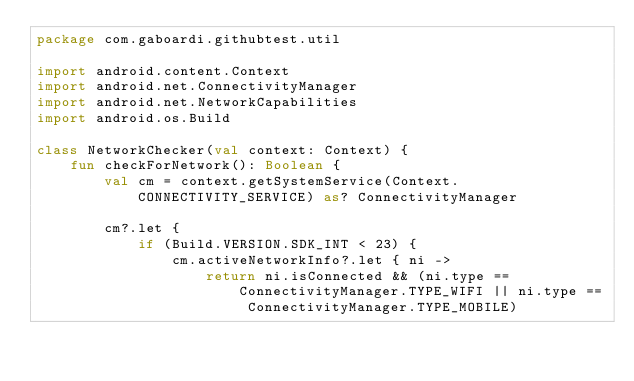<code> <loc_0><loc_0><loc_500><loc_500><_Kotlin_>package com.gaboardi.githubtest.util

import android.content.Context
import android.net.ConnectivityManager
import android.net.NetworkCapabilities
import android.os.Build

class NetworkChecker(val context: Context) {
    fun checkForNetwork(): Boolean {
        val cm = context.getSystemService(Context.CONNECTIVITY_SERVICE) as? ConnectivityManager

        cm?.let {
            if (Build.VERSION.SDK_INT < 23) {
                cm.activeNetworkInfo?.let { ni ->
                    return ni.isConnected && (ni.type == ConnectivityManager.TYPE_WIFI || ni.type == ConnectivityManager.TYPE_MOBILE)</code> 